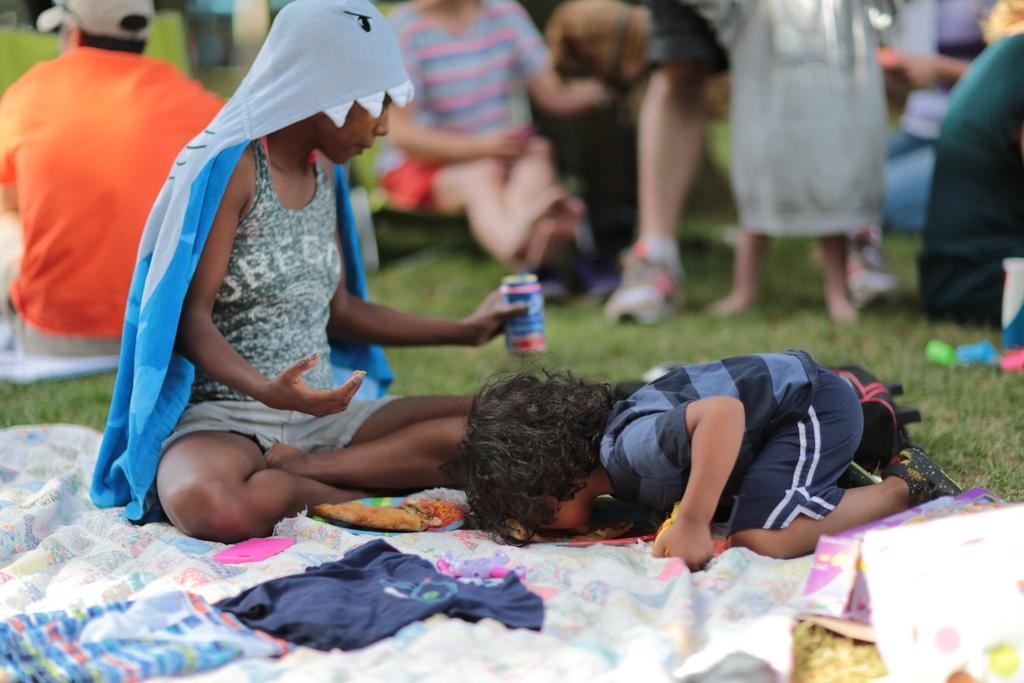Can you describe this image briefly? In this picture there is a person sitting and holding the tin and there is a person on knees. At the back there are group of people sitting and there are two persons standing. In the foreground there are clothes on the grass. 